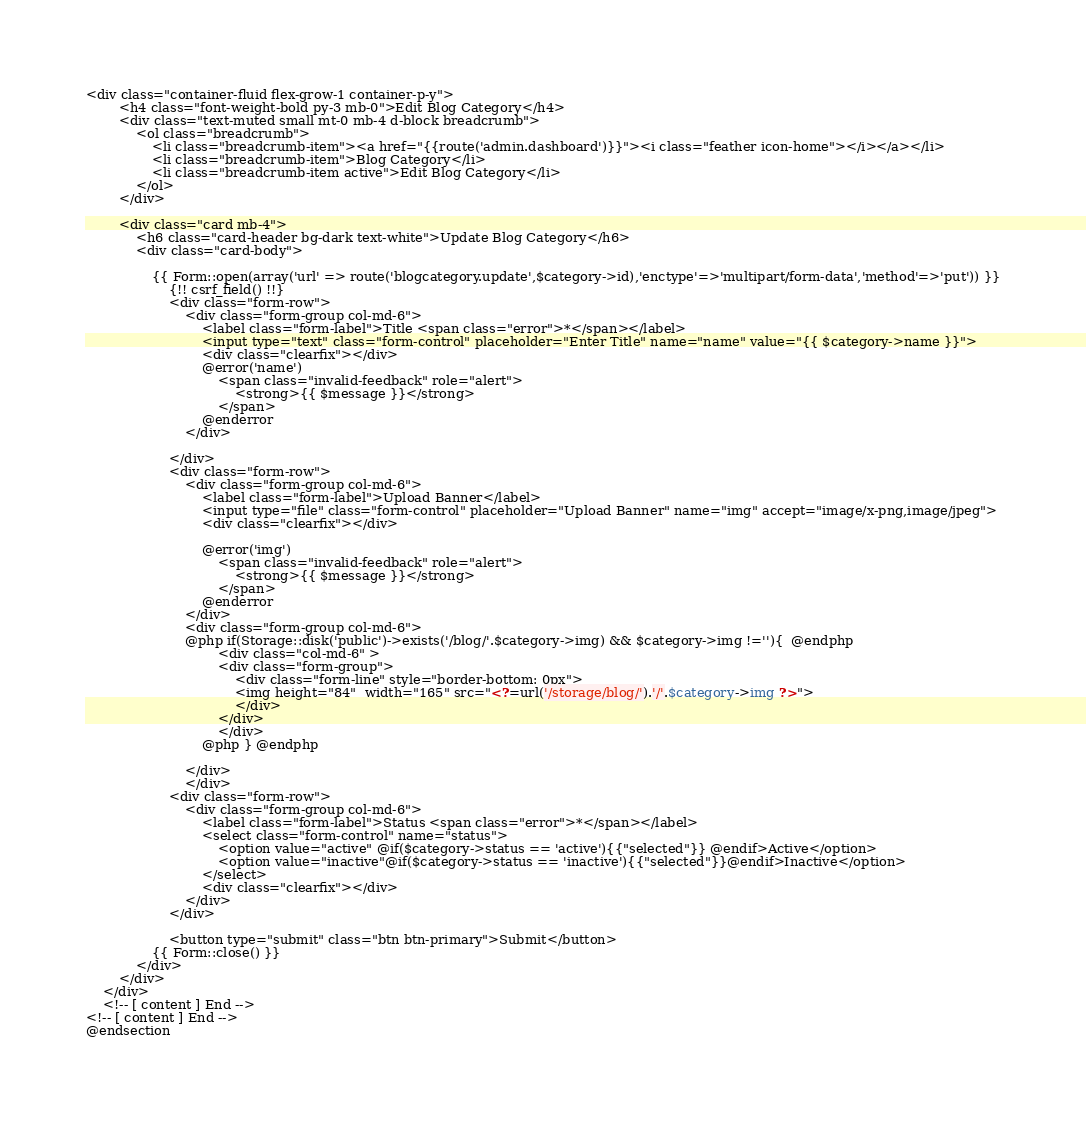Convert code to text. <code><loc_0><loc_0><loc_500><loc_500><_PHP_><div class="container-fluid flex-grow-1 container-p-y">
        <h4 class="font-weight-bold py-3 mb-0">Edit Blog Category</h4>
        <div class="text-muted small mt-0 mb-4 d-block breadcrumb">
            <ol class="breadcrumb">
                <li class="breadcrumb-item"><a href="{{route('admin.dashboard')}}"><i class="feather icon-home"></i></a></li>
                <li class="breadcrumb-item">Blog Category</li>
                <li class="breadcrumb-item active">Edit Blog Category</li>
            </ol>
        </div>

        <div class="card mb-4">
            <h6 class="card-header bg-dark text-white">Update Blog Category</h6>
            <div class="card-body">

                {{ Form::open(array('url' => route('blogcategory.update',$category->id),'enctype'=>'multipart/form-data','method'=>'put')) }}
                    {!! csrf_field() !!}
                    <div class="form-row">
                        <div class="form-group col-md-6">
                            <label class="form-label">Title <span class="error">*</span></label>
                            <input type="text" class="form-control" placeholder="Enter Title" name="name" value="{{ $category->name }}">
                            <div class="clearfix"></div>
                            @error('name')
                                <span class="invalid-feedback" role="alert">
                                    <strong>{{ $message }}</strong>
                                </span>
                            @enderror
                        </div>
                       
                    </div>
                    <div class="form-row">
                        <div class="form-group col-md-6">
                            <label class="form-label">Upload Banner</label>
                            <input type="file" class="form-control" placeholder="Upload Banner" name="img" accept="image/x-png,image/jpeg">
                            <div class="clearfix"></div>
                           
                            @error('img')
                                <span class="invalid-feedback" role="alert">
                                    <strong>{{ $message }}</strong>
                                </span>
                            @enderror
                        </div>
                        <div class="form-group col-md-6">
                        @php if(Storage::disk('public')->exists('/blog/'.$category->img) && $category->img !=''){  @endphp
                                <div class="col-md-6" > 
                                <div class="form-group">
                                    <div class="form-line" style="border-bottom: 0px">
                                    <img height="84"  width="165" src="<?=url('/storage/blog/').'/'.$category->img ?>">
                                    </div>
                                </div>
                                </div>
                            @php } @endphp  

                        </div>
                        </div>
                    <div class="form-row">
                        <div class="form-group col-md-6">
                            <label class="form-label">Status <span class="error">*</span></label>
                            <select class="form-control" name="status">
                                <option value="active" @if($category->status == 'active'){{"selected"}} @endif>Active</option>
                                <option value="inactive"@if($category->status == 'inactive'){{"selected"}}@endif>Inactive</option>
                            </select>
                            <div class="clearfix"></div>
                        </div>
                    </div>
                    
                    <button type="submit" class="btn btn-primary">Submit</button>
                {{ Form::close() }}
            </div>
        </div>
    </div>
    <!-- [ content ] End -->
<!-- [ content ] End -->
@endsection</code> 